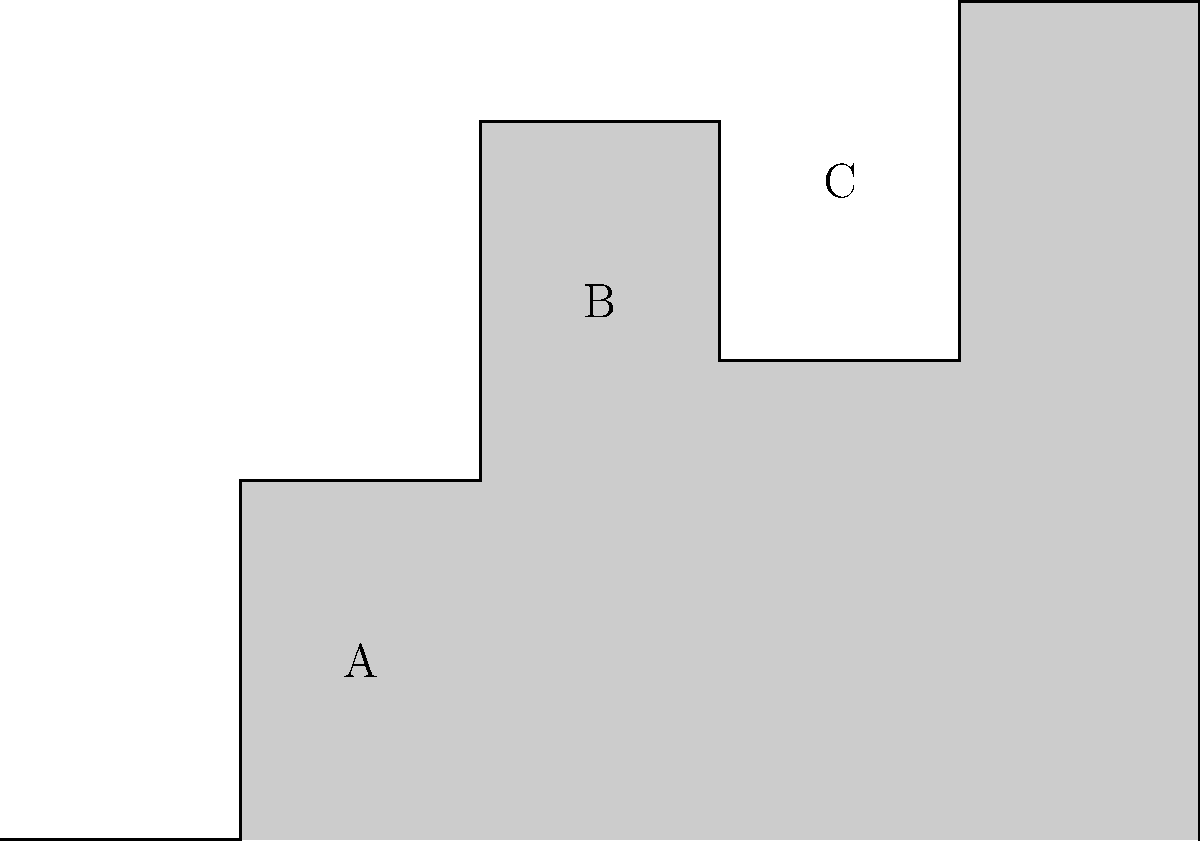Which of the labeled structures in this simplified skyline of Guadalajara most likely represents the iconic Guadalajara Cathedral? To identify the Guadalajara Cathedral in this simplified skyline, let's consider the characteristics of each labeled structure:

1. Structure A: This is a relatively short and wide building, which doesn't match the typical cathedral architecture.

2. Structure B: This building is taller than A and has a more distinct shape, with two peaks. This is characteristic of the Guadalajara Cathedral, which is known for its twin spires.

3. Structure C: While taller than A, this structure lacks the distinctive twin-peak design that would be expected for the cathedral.

The Guadalajara Cathedral, or Catedral de la Asunción de María Santísima, is one of the most recognizable landmarks in the city. It features a distinct silhouette with two tall spires that dominate the skyline of the historic center. 

Given this information, structure B most closely resembles the profile of the Guadalajara Cathedral with its two prominent peaks representing the twin spires.
Answer: B 